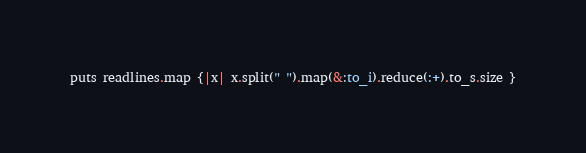<code> <loc_0><loc_0><loc_500><loc_500><_Ruby_>puts readlines.map {|x| x.split(" ").map(&:to_i).reduce(:+).to_s.size }</code> 